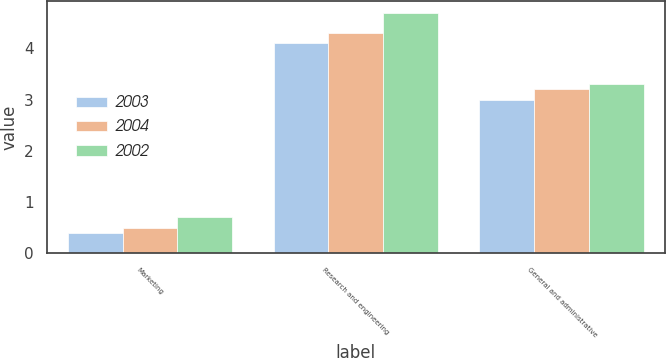<chart> <loc_0><loc_0><loc_500><loc_500><stacked_bar_chart><ecel><fcel>Marketing<fcel>Research and engineering<fcel>General and administrative<nl><fcel>2003<fcel>0.4<fcel>4.1<fcel>3<nl><fcel>2004<fcel>0.5<fcel>4.3<fcel>3.2<nl><fcel>2002<fcel>0.7<fcel>4.7<fcel>3.3<nl></chart> 